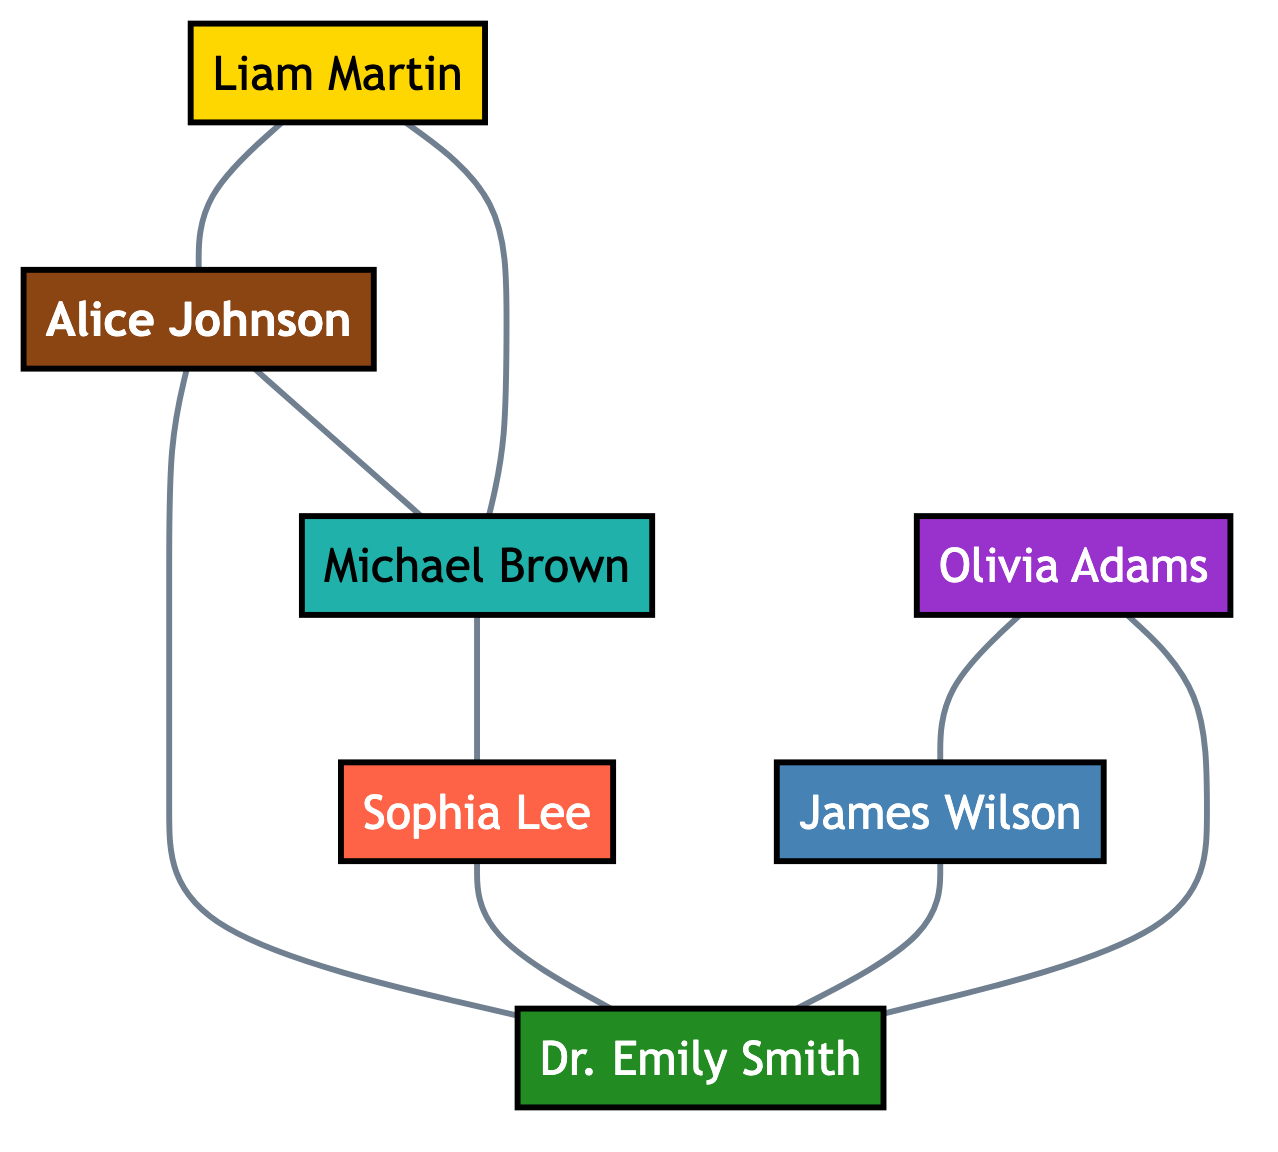What is the total number of scientists in the collaboration network? Counting the number of unique nodes listed in the diagram, we find there are 7 scientists: Alice Johnson, Dr. Emily Smith, Michael Brown, Sophia Lee, James Wilson, Olivia Adams, and Liam Martin.
Answer: 7 Which node is connected to both Alice Johnson and Dr. Emily Smith? By examining the edges, we can see that Michael Brown is connected to Alice Johnson and is also connected to Dr. Emily Smith.
Answer: Michael Brown What role does Liam Martin have in the project? Looking at the node labeled "Liam Martin," the role mentioned is PhD Student.
Answer: PhD Student How many collaborations does Dr. Emily Smith have? By reviewing the edges connected to Dr. Emily Smith, we find there are 4 connections; they are with Alice Johnson, Michael Brown, James Wilson, and Olivia Adams.
Answer: 4 Is there a connection between Sophia Lee and Michael Brown? Checking the edges reveals there is a direct connection labeled "Field Work and Taxonomy" between Sophia Lee and Michael Brown.
Answer: Yes What is the relationship between Olivia Adams and James Wilson? The edge indicates that Olivia Adams and James Wilson are connected by "Data Analysis."
Answer: Data Analysis Who supervises Liam Martin? The edge shows that Alice Johnson is the one connected to Liam Martin with the relation "Student Supervisor."
Answer: Alice Johnson How many edges are present in the network? Counting all the edges in the diagram gives a total of 8, as each relationship between nodes represents one edge.
Answer: 8 What type of work is James Wilson involved in? The role of James Wilson is labeled as Lab Technician, and he has a connection with Dr. Emily Smith for "Lab Work."
Answer: Lab Work 